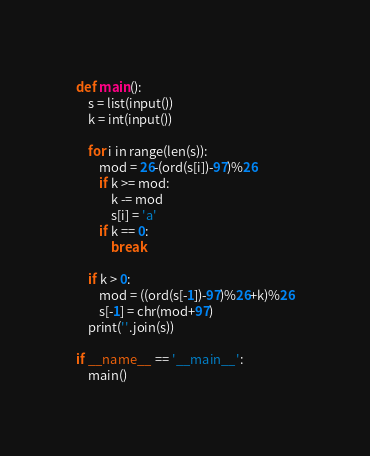Convert code to text. <code><loc_0><loc_0><loc_500><loc_500><_Python_>def main():
    s = list(input())
    k = int(input())

    for i in range(len(s)):
        mod = 26-(ord(s[i])-97)%26
        if k >= mod:
            k -= mod
            s[i] = 'a'
        if k == 0:
            break
    
    if k > 0:
        mod = ((ord(s[-1])-97)%26+k)%26
        s[-1] = chr(mod+97)
    print(''.join(s))

if __name__ == '__main__':
    main()

</code> 